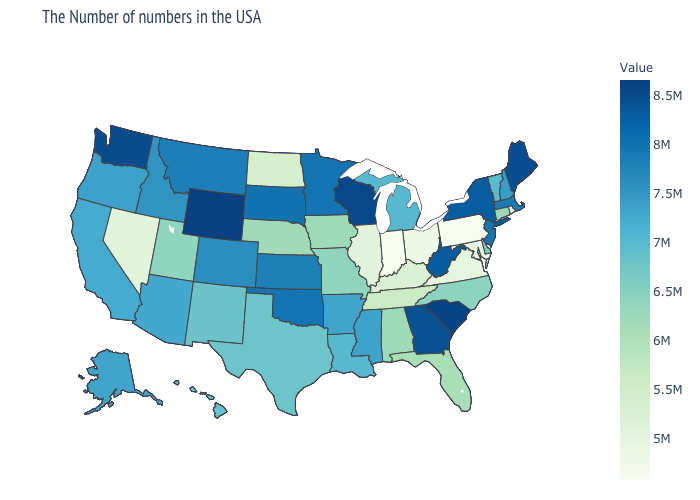Does Michigan have a higher value than South Carolina?
Write a very short answer. No. Among the states that border Delaware , does Maryland have the highest value?
Quick response, please. No. Does Montana have a lower value than Louisiana?
Short answer required. No. Does New Jersey have the highest value in the Northeast?
Be succinct. No. Does the map have missing data?
Give a very brief answer. No. 